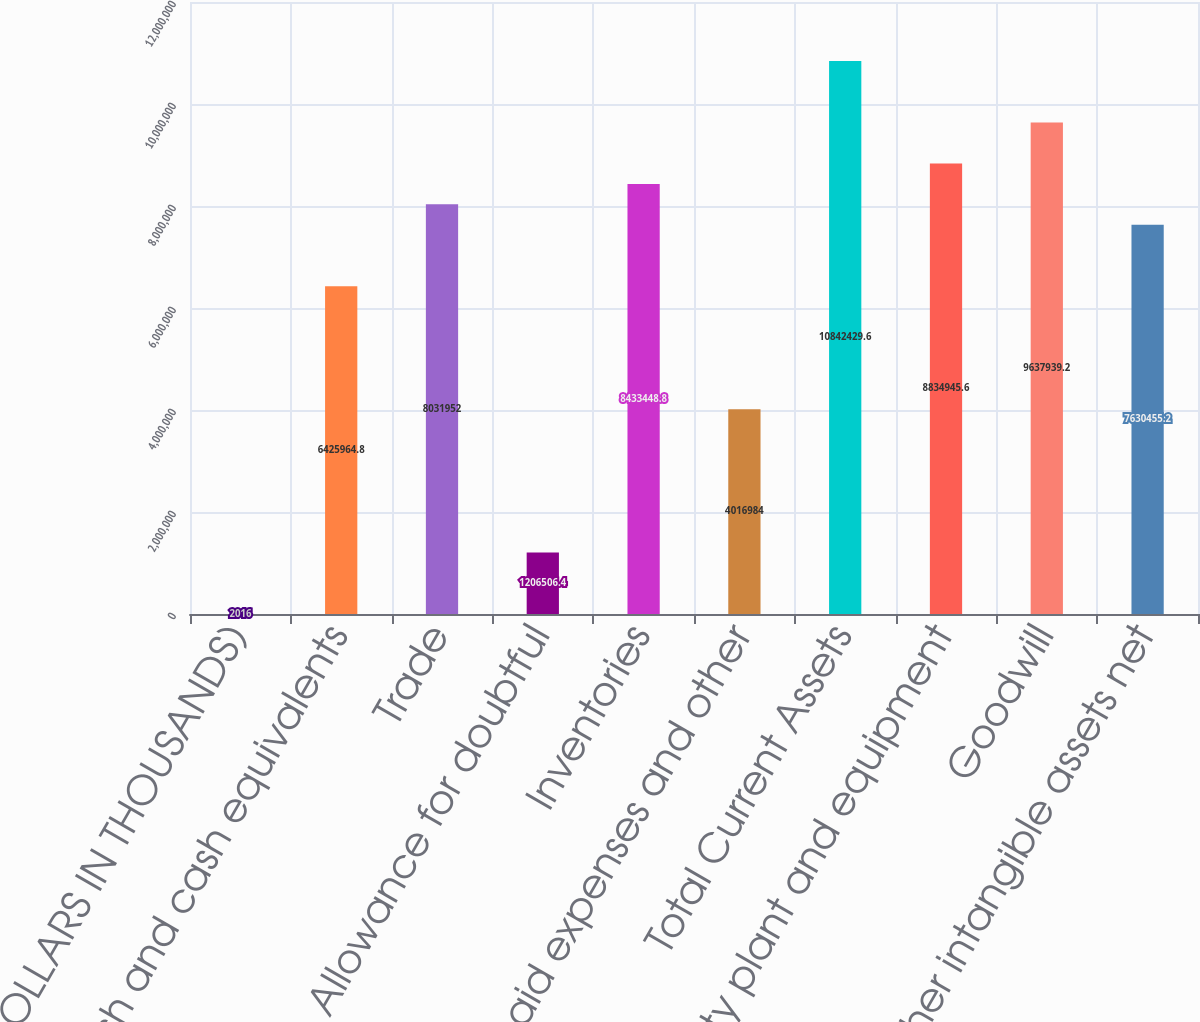Convert chart to OTSL. <chart><loc_0><loc_0><loc_500><loc_500><bar_chart><fcel>(DOLLARS IN THOUSANDS)<fcel>Cash and cash equivalents<fcel>Trade<fcel>Allowance for doubtful<fcel>Inventories<fcel>Prepaid expenses and other<fcel>Total Current Assets<fcel>Property plant and equipment<fcel>Goodwill<fcel>Other intangible assets net<nl><fcel>2016<fcel>6.42596e+06<fcel>8.03195e+06<fcel>1.20651e+06<fcel>8.43345e+06<fcel>4.01698e+06<fcel>1.08424e+07<fcel>8.83495e+06<fcel>9.63794e+06<fcel>7.63046e+06<nl></chart> 